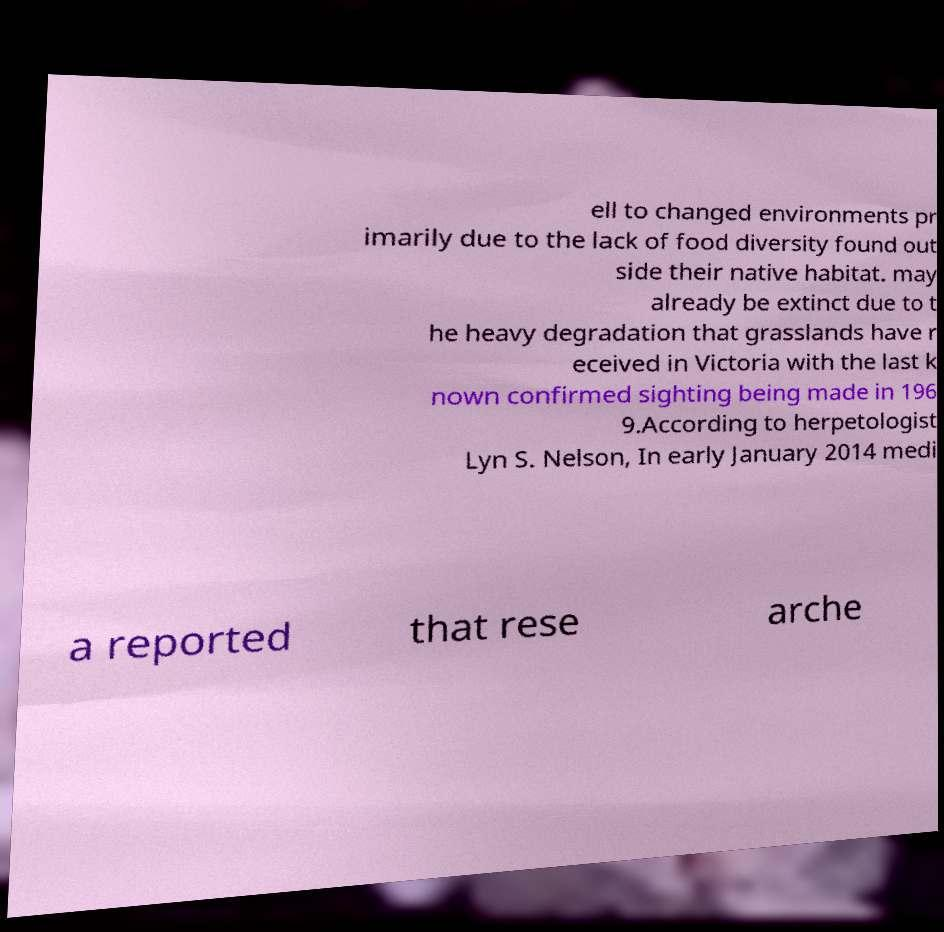Could you extract and type out the text from this image? ell to changed environments pr imarily due to the lack of food diversity found out side their native habitat. may already be extinct due to t he heavy degradation that grasslands have r eceived in Victoria with the last k nown confirmed sighting being made in 196 9.According to herpetologist Lyn S. Nelson, In early January 2014 medi a reported that rese arche 